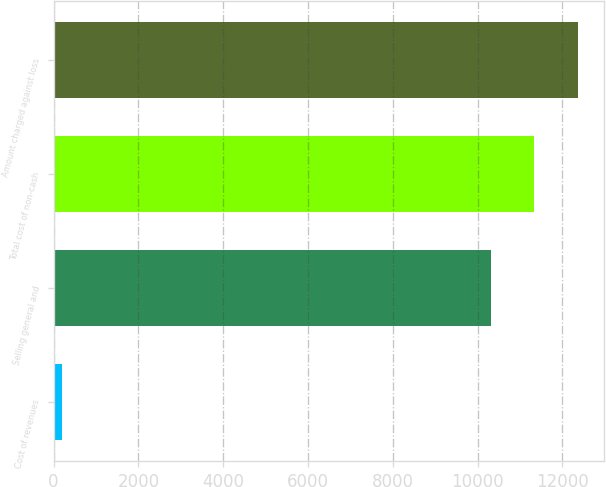Convert chart. <chart><loc_0><loc_0><loc_500><loc_500><bar_chart><fcel>Cost of revenues<fcel>Selling general and<fcel>Total cost of non-cash<fcel>Amount charged against loss<nl><fcel>189<fcel>10312<fcel>11343.2<fcel>12374.4<nl></chart> 